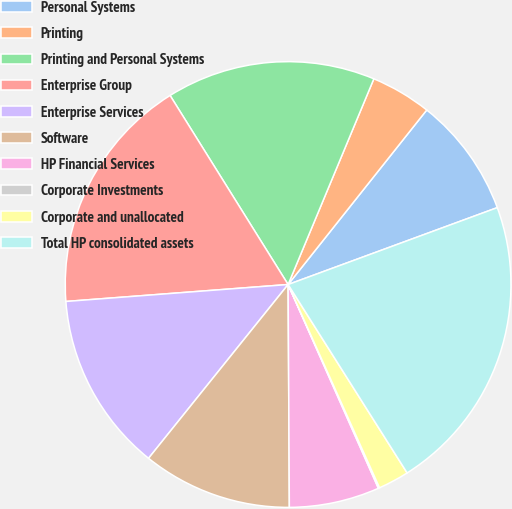Convert chart. <chart><loc_0><loc_0><loc_500><loc_500><pie_chart><fcel>Personal Systems<fcel>Printing<fcel>Printing and Personal Systems<fcel>Enterprise Group<fcel>Enterprise Services<fcel>Software<fcel>HP Financial Services<fcel>Corporate Investments<fcel>Corporate and unallocated<fcel>Total HP consolidated assets<nl><fcel>8.71%<fcel>4.4%<fcel>15.17%<fcel>17.33%<fcel>13.02%<fcel>10.86%<fcel>6.55%<fcel>0.09%<fcel>2.24%<fcel>21.64%<nl></chart> 